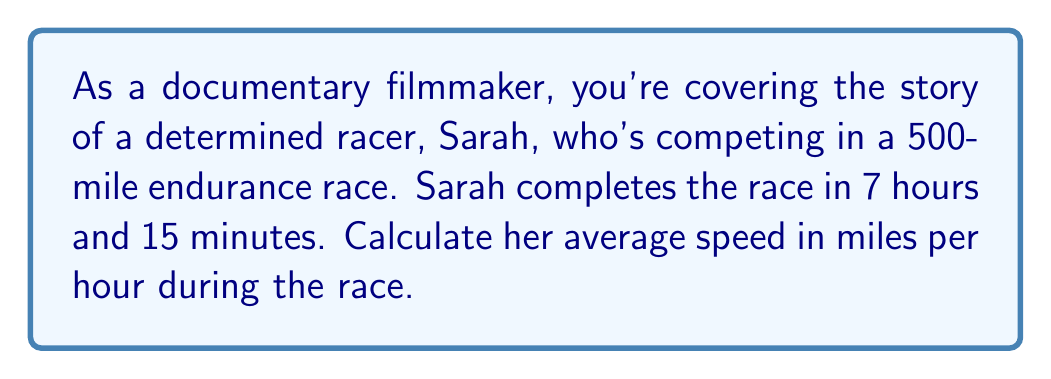Can you solve this math problem? To solve this problem, we'll use the formula for average speed:

$$ \text{Average Speed} = \frac{\text{Total Distance}}{\text{Total Time}} $$

Let's break down the given information:
1. Total Distance = 500 miles
2. Total Time = 7 hours and 15 minutes

First, we need to convert the time to hours:
15 minutes = 0.25 hours
Total Time = 7 + 0.25 = 7.25 hours

Now, we can plug these values into our formula:

$$ \text{Average Speed} = \frac{500 \text{ miles}}{7.25 \text{ hours}} $$

$$ \text{Average Speed} = 68.97 \text{ miles per hour} $$

Rounding to two decimal places, we get 68.97 mph.
Answer: Sarah's average speed during the race was 68.97 mph. 